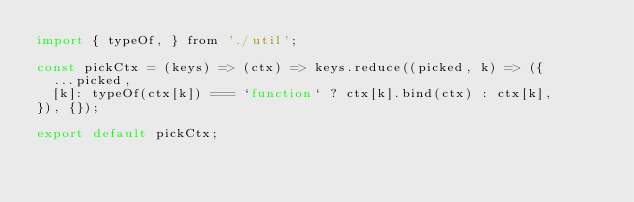Convert code to text. <code><loc_0><loc_0><loc_500><loc_500><_JavaScript_>import { typeOf, } from './util';

const pickCtx = (keys) => (ctx) => keys.reduce((picked, k) => ({
  ...picked,
  [k]: typeOf(ctx[k]) === `function` ? ctx[k].bind(ctx) : ctx[k],
}), {});

export default pickCtx;
</code> 